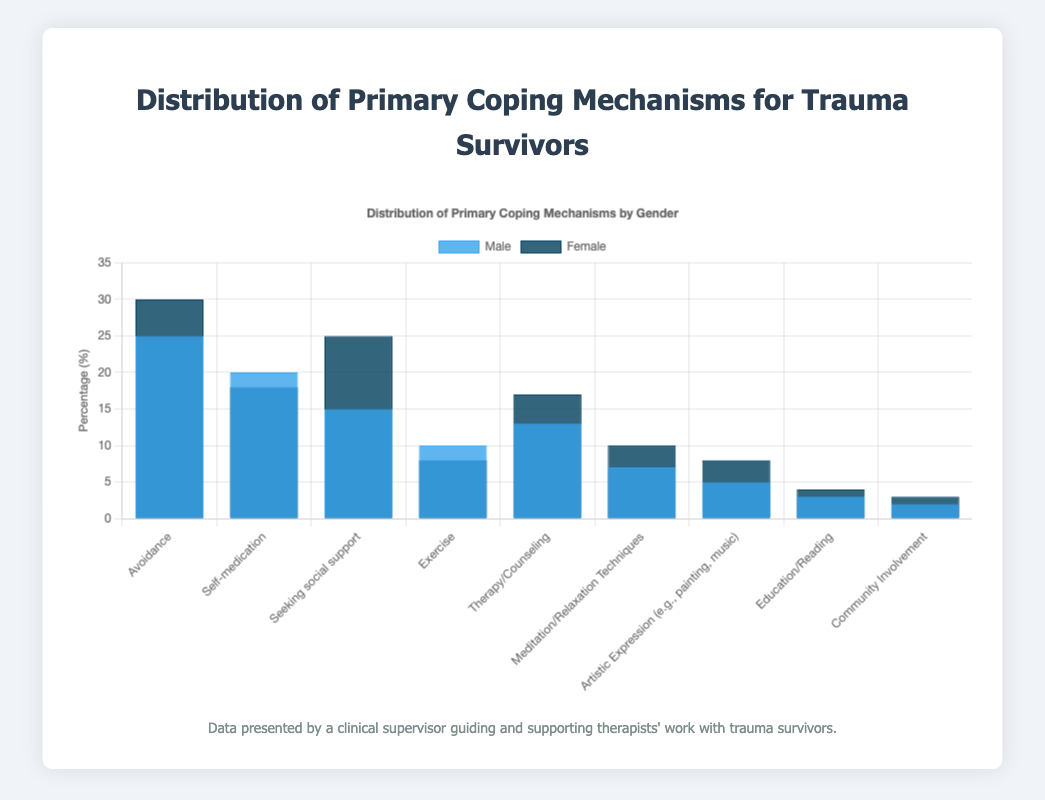What is the primary coping mechanism utilized by the highest percentage of females? The bar chart shows different coping mechanisms with percentages for males and females. By visually inspecting the bars for females, the tallest bar represents the primary coping mechanism utilized by the highest percentage of females. In this case, it is 'Avoidance.'
Answer: Avoidance Which coping mechanism shows the largest difference in utilization percentage between males and females? To find this, calculate the difference in percentages for each coping mechanism, and identify which has the largest difference. The calculations are: Avoidance (5), Self-medication (2), Seeking social support (10), Exercise (2), Therapy/Counseling (4), Meditation/Relaxation Techniques (3), Artistic Expression (3), Education/Reading (1), Community Involvement (1). The largest difference is for 'Seeking social support' (10%).
Answer: Seeking social support What is the combined percentage of males utilizing 'Self-medication' and 'Exercise' as their primary coping mechanisms? Sum the percentages for males in 'Self-medication' and 'Exercise': Self-medication (20) + Exercise (10) = 30.
Answer: 30% Which coping mechanism is utilized by more males than females? Compare the height of the bars for males and females for each coping mechanism. 'Self-medication' and 'Exercise' are the coping mechanisms where the male bar is taller.
Answer: Self-medication and Exercise What is the total percentage of females utilizing either 'Therapy/Counseling' or 'Meditation/Relaxation Techniques'? Add the percentages for females in 'Therapy/Counseling' and 'Meditation/Relaxation Techniques': Therapy/Counseling (17) + Meditation/Relaxation Techniques (10) = 27.
Answer: 27% Between 'Avoidance' and 'Therapy/Counseling,' which coping mechanism has a greater percentage difference between males and females? Calculate the percentage difference for both mechanisms: Avoidance (5%) and Therapy/Counseling (4%). 'Avoidance' has the greater percentage difference.
Answer: Avoidance How does the utilization percentage of 'Community Involvement' compare between males and females? Look at the bars for 'Community Involvement' and compare the heights. The percentage for males (2%) is slightly lower than for females (3%).
Answer: Females (3%) > Males (2%) What is the average percentage of females utilizing 'Artistic Expression' and 'Education/Reading'? Calculate the average: (Artistic Expression 8 + Education/Reading 4) / 2 = 6.
Answer: 6% Which gender utilizes 'Seeking Social Support' as a coping mechanism more frequently? Check the bars for 'Seeking Social Support' and compare. The female percentage (25) is much higher than the male percentage (15).
Answer: Females 